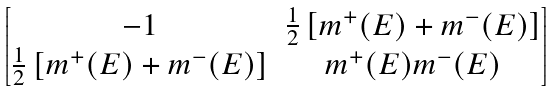Convert formula to latex. <formula><loc_0><loc_0><loc_500><loc_500>\begin{bmatrix} - 1 & \frac { 1 } { 2 } \left [ m ^ { + } ( E ) + m ^ { - } ( E ) \right ] \\ \frac { 1 } { 2 } \left [ m ^ { + } ( E ) + m ^ { - } ( E ) \right ] & m ^ { + } ( E ) m ^ { - } ( E ) \end{bmatrix}</formula> 